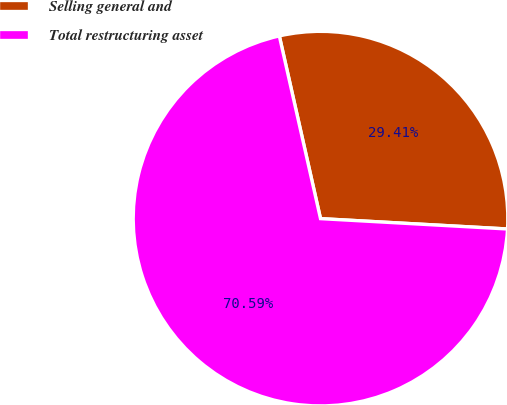Convert chart. <chart><loc_0><loc_0><loc_500><loc_500><pie_chart><fcel>Selling general and<fcel>Total restructuring asset<nl><fcel>29.41%<fcel>70.59%<nl></chart> 